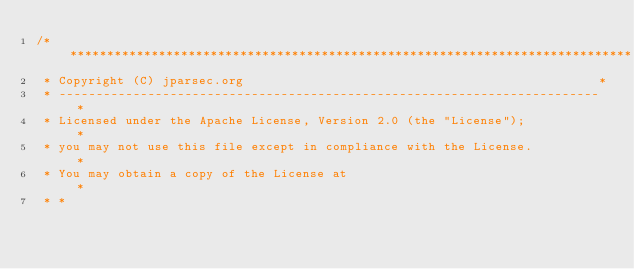<code> <loc_0><loc_0><loc_500><loc_500><_Kotlin_>/*****************************************************************************
 * Copyright (C) jparsec.org                                                *
 * ------------------------------------------------------------------------- *
 * Licensed under the Apache License, Version 2.0 (the "License");           *
 * you may not use this file except in compliance with the License.          *
 * You may obtain a copy of the License at                                   *
 * *</code> 